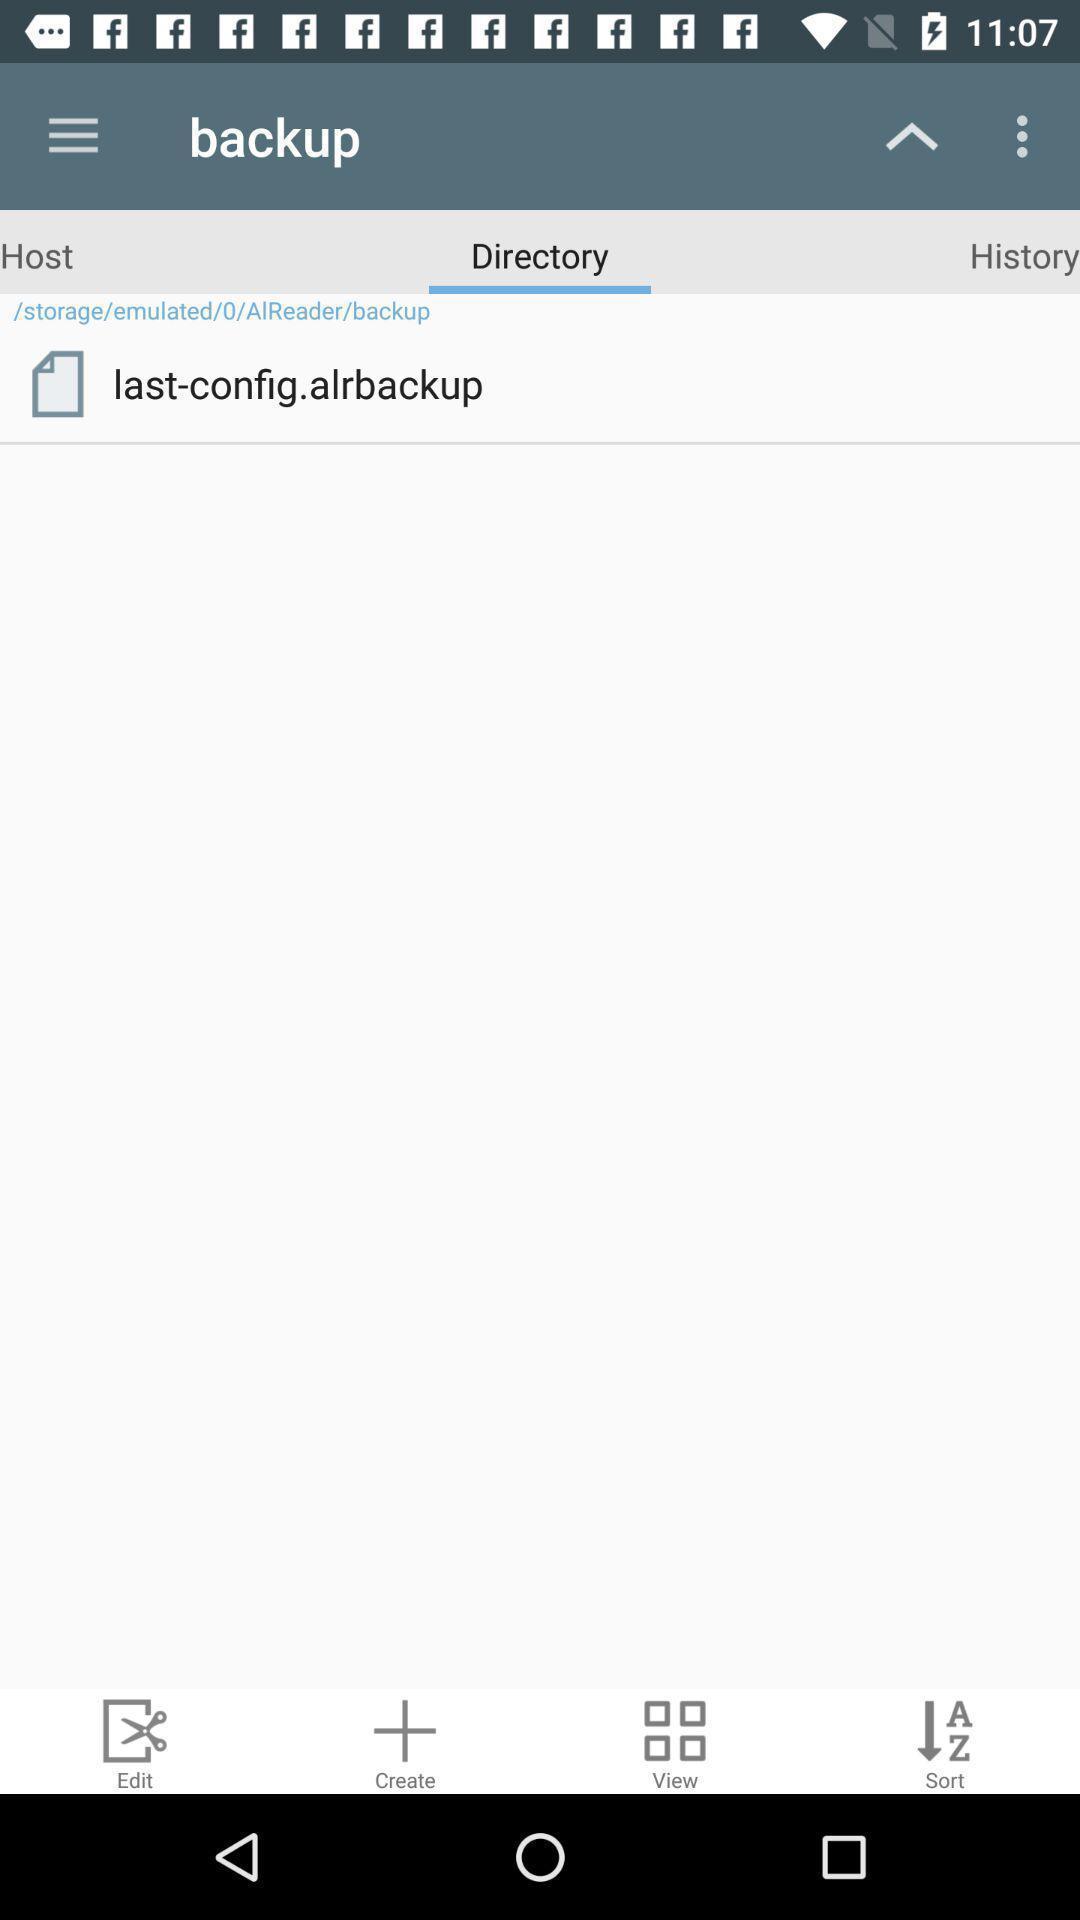Describe the content in this image. Page displaying the backup file. 